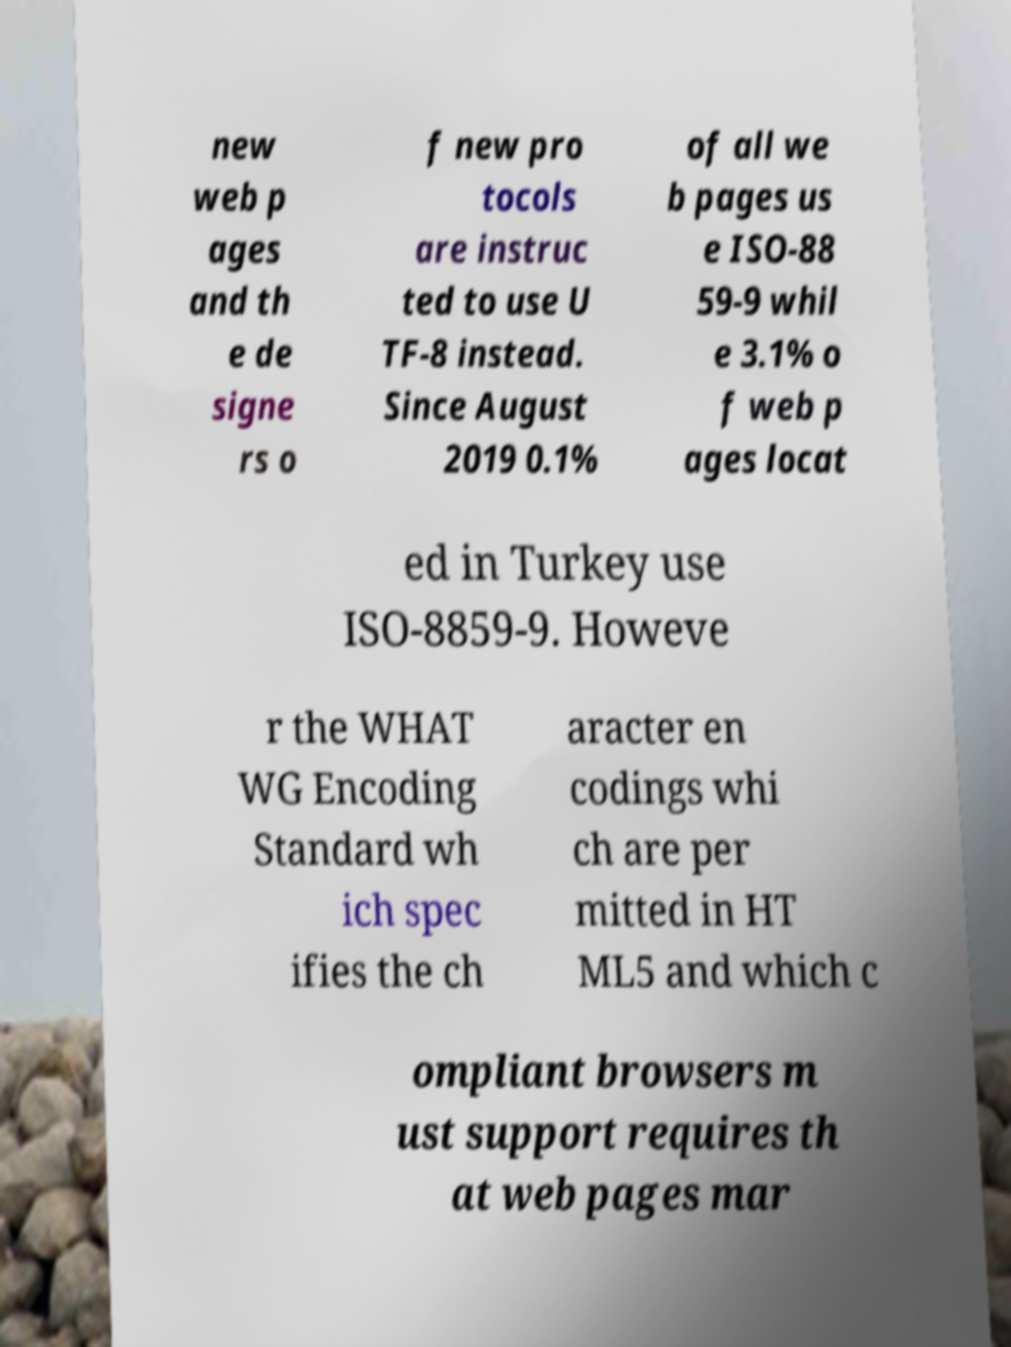Can you accurately transcribe the text from the provided image for me? new web p ages and th e de signe rs o f new pro tocols are instruc ted to use U TF-8 instead. Since August 2019 0.1% of all we b pages us e ISO-88 59-9 whil e 3.1% o f web p ages locat ed in Turkey use ISO-8859-9. Howeve r the WHAT WG Encoding Standard wh ich spec ifies the ch aracter en codings whi ch are per mitted in HT ML5 and which c ompliant browsers m ust support requires th at web pages mar 